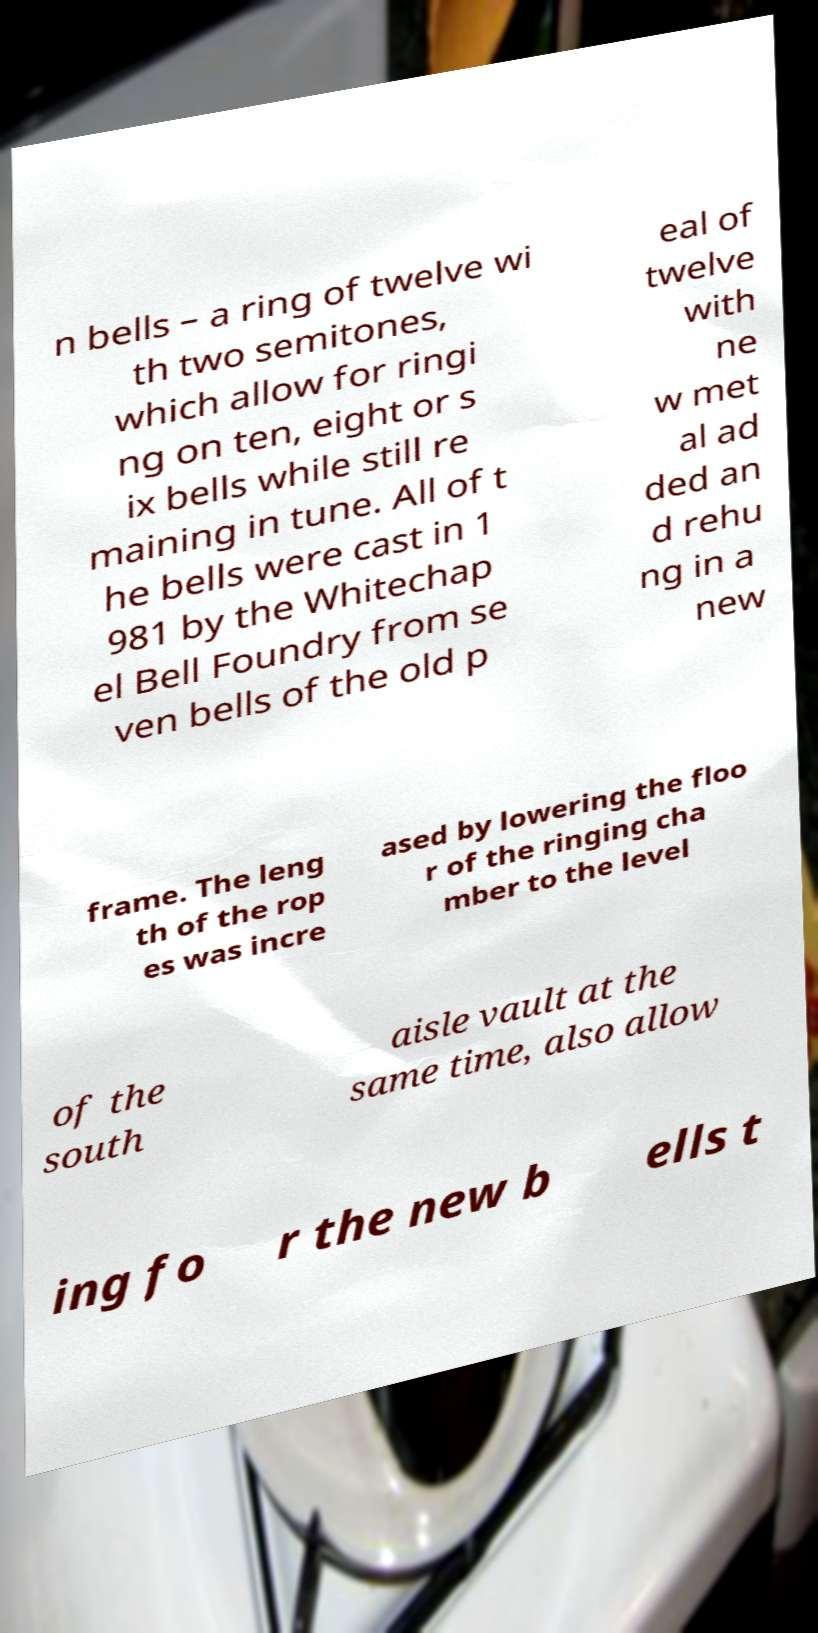Could you assist in decoding the text presented in this image and type it out clearly? n bells – a ring of twelve wi th two semitones, which allow for ringi ng on ten, eight or s ix bells while still re maining in tune. All of t he bells were cast in 1 981 by the Whitechap el Bell Foundry from se ven bells of the old p eal of twelve with ne w met al ad ded an d rehu ng in a new frame. The leng th of the rop es was incre ased by lowering the floo r of the ringing cha mber to the level of the south aisle vault at the same time, also allow ing fo r the new b ells t 